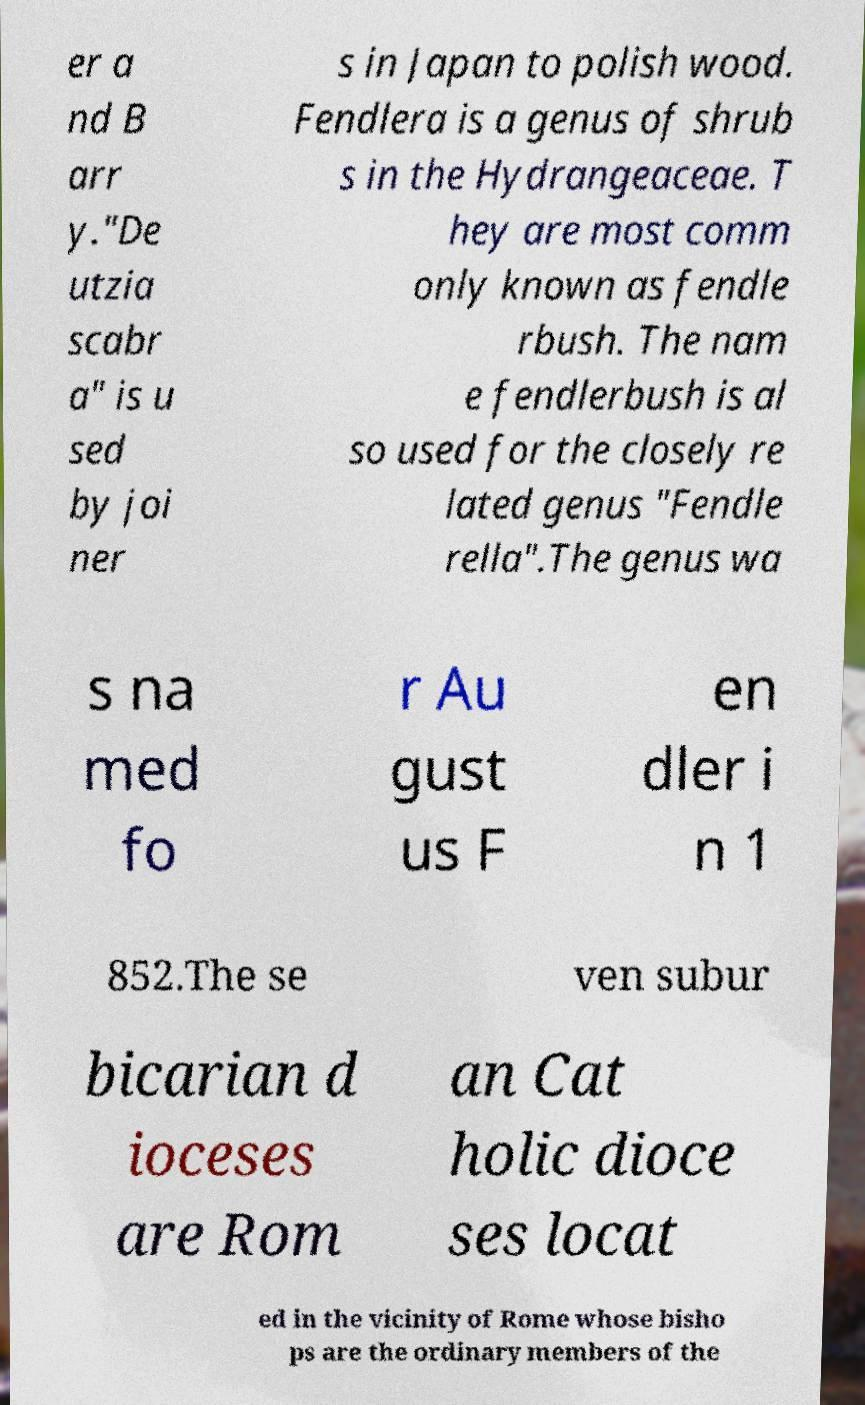I need the written content from this picture converted into text. Can you do that? er a nd B arr y."De utzia scabr a" is u sed by joi ner s in Japan to polish wood. Fendlera is a genus of shrub s in the Hydrangeaceae. T hey are most comm only known as fendle rbush. The nam e fendlerbush is al so used for the closely re lated genus "Fendle rella".The genus wa s na med fo r Au gust us F en dler i n 1 852.The se ven subur bicarian d ioceses are Rom an Cat holic dioce ses locat ed in the vicinity of Rome whose bisho ps are the ordinary members of the 